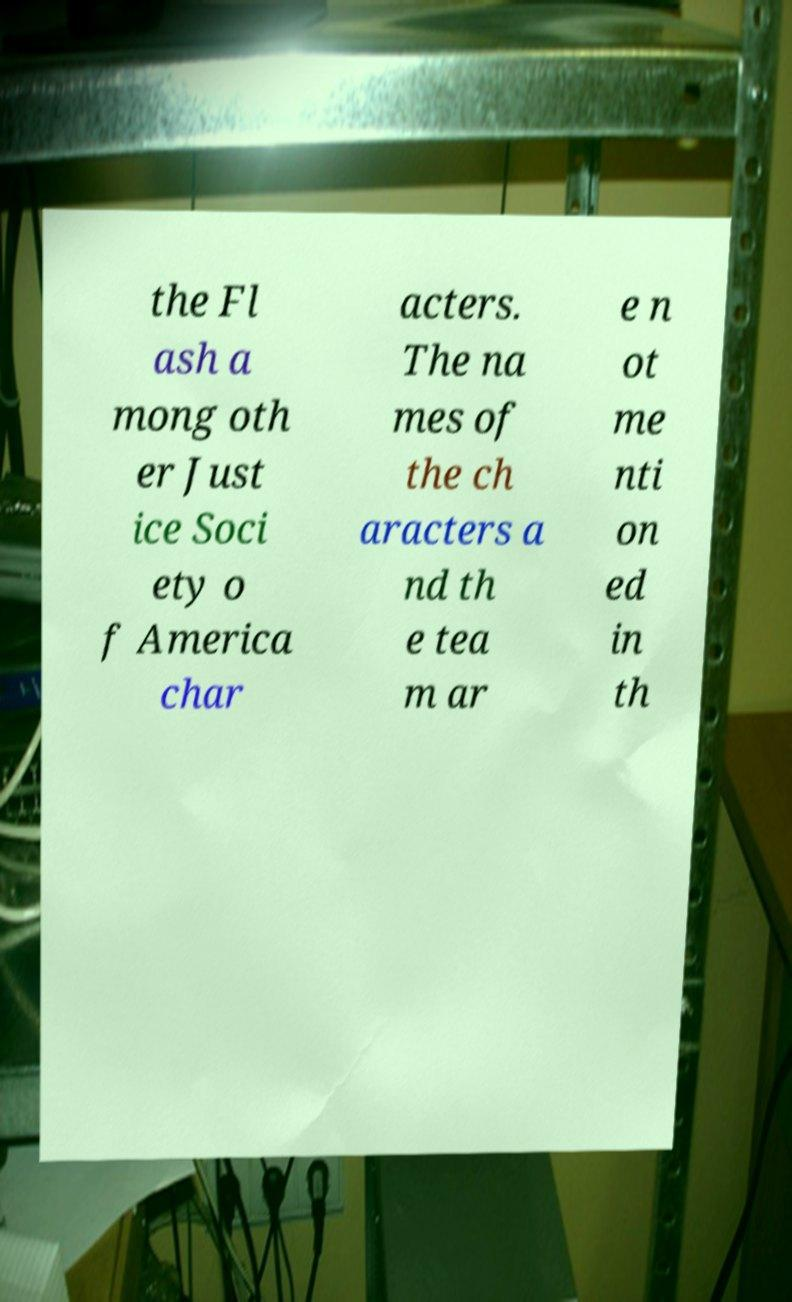There's text embedded in this image that I need extracted. Can you transcribe it verbatim? the Fl ash a mong oth er Just ice Soci ety o f America char acters. The na mes of the ch aracters a nd th e tea m ar e n ot me nti on ed in th 